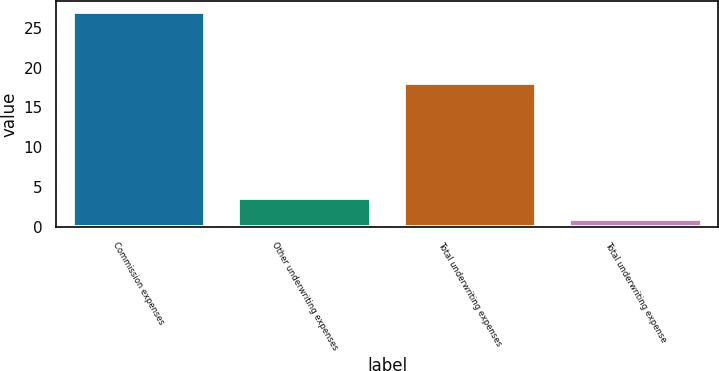Convert chart. <chart><loc_0><loc_0><loc_500><loc_500><bar_chart><fcel>Commission expenses<fcel>Other underwriting expenses<fcel>Total underwriting expenses<fcel>Total underwriting expense<nl><fcel>27<fcel>3.6<fcel>18<fcel>1<nl></chart> 